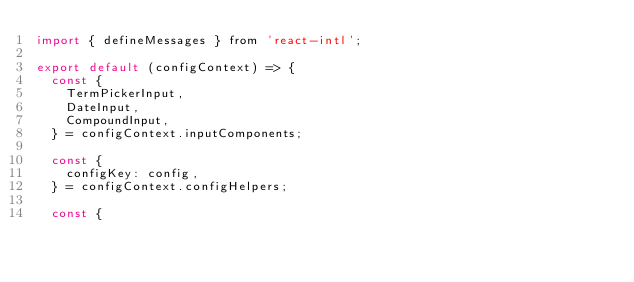<code> <loc_0><loc_0><loc_500><loc_500><_JavaScript_>import { defineMessages } from 'react-intl';

export default (configContext) => {
  const {
    TermPickerInput,
    DateInput,
    CompoundInput,
  } = configContext.inputComponents;

  const {
    configKey: config,
  } = configContext.configHelpers;

  const {</code> 